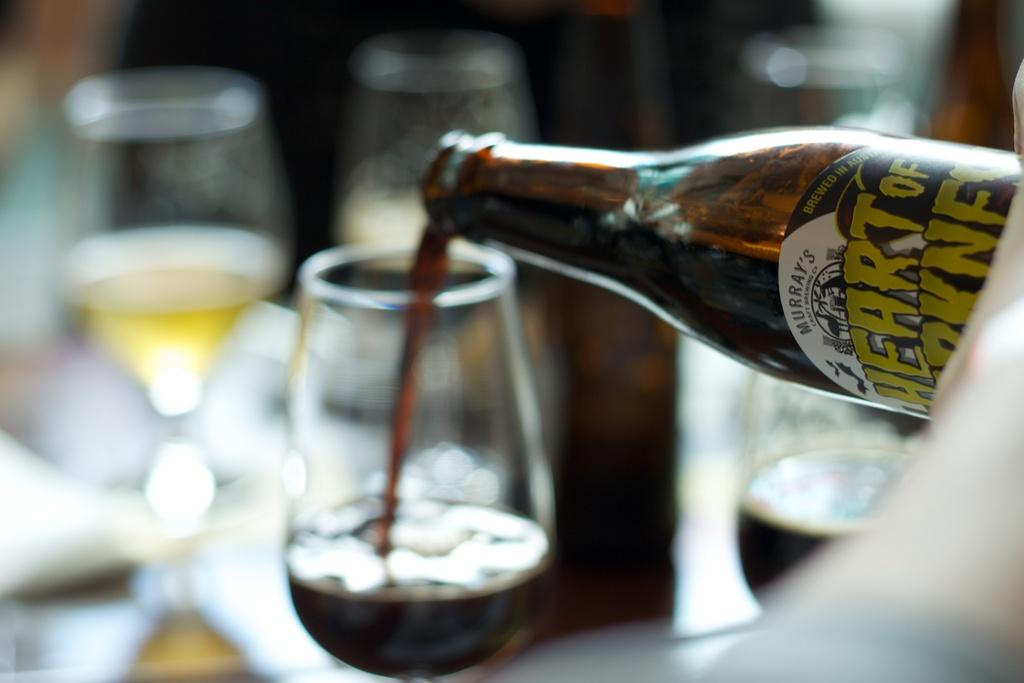What is one of the objects visible in the image? There is a bottle in the image. What else can be seen in the image? There are glasses in the image. What type of steel is used to make the stew in the image? There is no stew present in the image, and therefore no steel or any cooking process can be observed. Who is the owner of the bottle and glasses in the image? The image does not provide any information about the ownership of the bottle and glasses. 